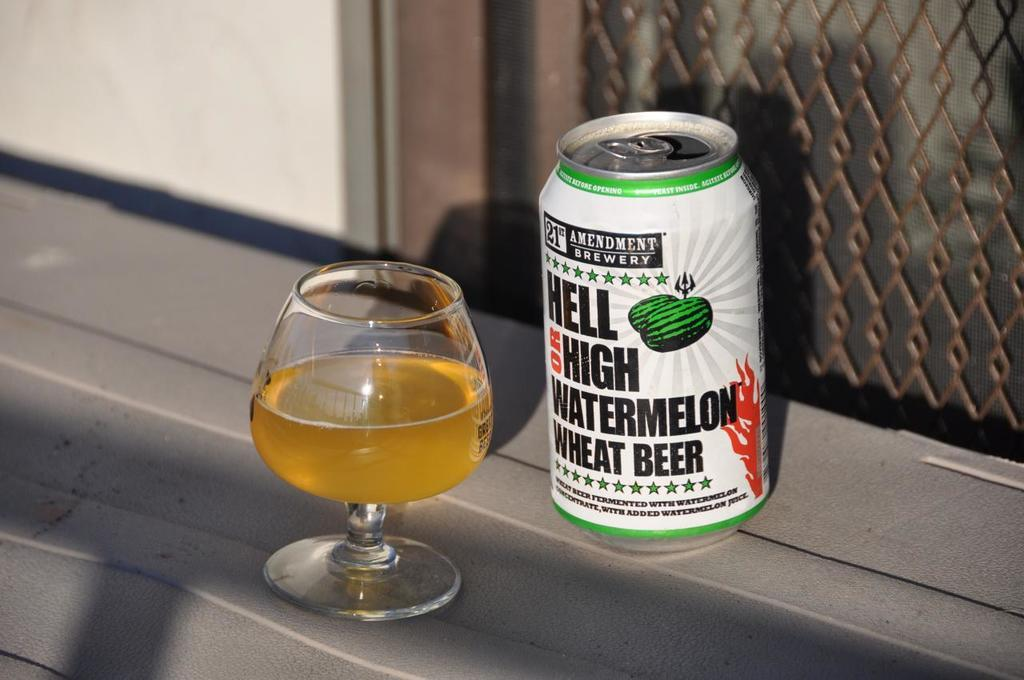<image>
Provide a brief description of the given image. a can that has the word hell high on it 